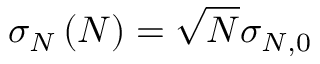<formula> <loc_0><loc_0><loc_500><loc_500>\sigma _ { N } \left ( N \right ) = \sqrt { N } \sigma _ { N , 0 }</formula> 